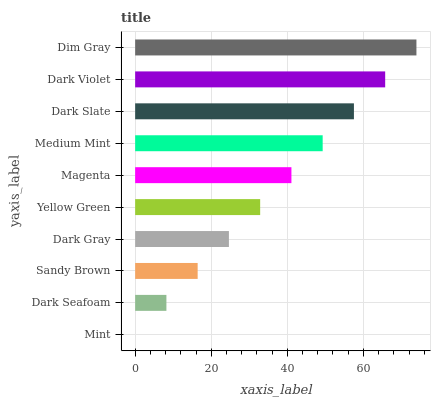Is Mint the minimum?
Answer yes or no. Yes. Is Dim Gray the maximum?
Answer yes or no. Yes. Is Dark Seafoam the minimum?
Answer yes or no. No. Is Dark Seafoam the maximum?
Answer yes or no. No. Is Dark Seafoam greater than Mint?
Answer yes or no. Yes. Is Mint less than Dark Seafoam?
Answer yes or no. Yes. Is Mint greater than Dark Seafoam?
Answer yes or no. No. Is Dark Seafoam less than Mint?
Answer yes or no. No. Is Magenta the high median?
Answer yes or no. Yes. Is Yellow Green the low median?
Answer yes or no. Yes. Is Sandy Brown the high median?
Answer yes or no. No. Is Sandy Brown the low median?
Answer yes or no. No. 